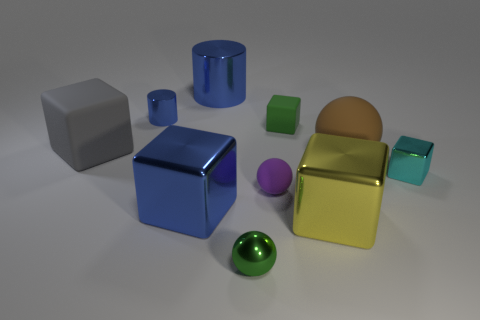What can you infer about the lighting in the scene? The scene is illuminated by a diffuse light source, as indicated by the soft shadows cast under the objects. The highlights on the objects suggest the light source could be positioned above them, offering a neutral daylight ambiance. 